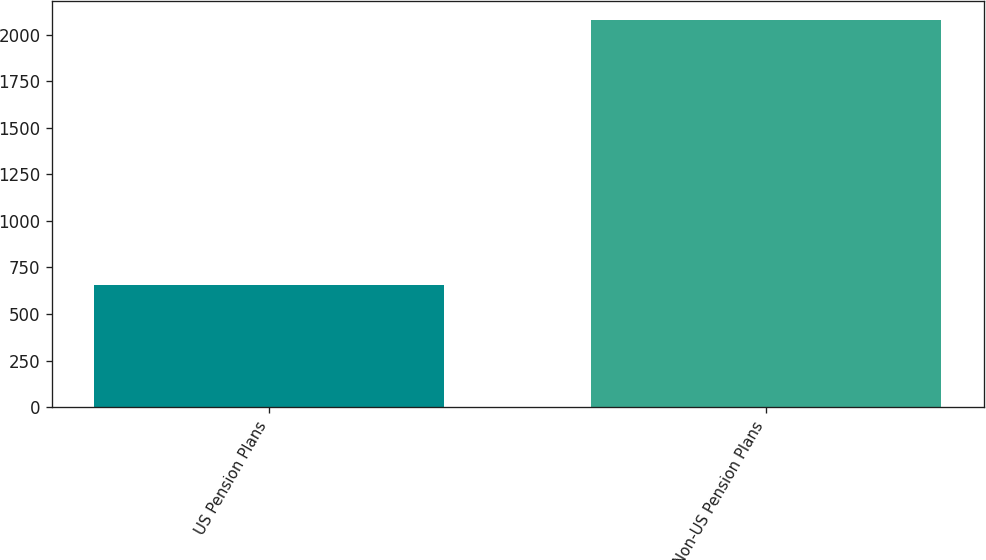Convert chart. <chart><loc_0><loc_0><loc_500><loc_500><bar_chart><fcel>US Pension Plans<fcel>Non-US Pension Plans<nl><fcel>657<fcel>2077<nl></chart> 